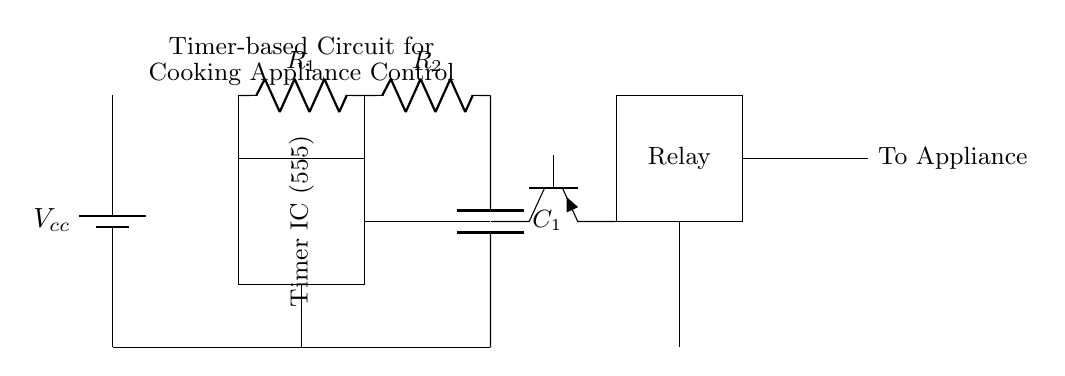What type of timer is used in this circuit? The circuit employs a 555 timer, which is indicated as "Timer IC (555)" in the diagram.
Answer: 555 timer What is the purpose of the capacitor in this circuit? The capacitor, labeled as C1, is used in conjunction with the resistors to determine the timing interval for the circuit, influencing how long the cooking appliance will be active.
Answer: Timing interval What is the role of the relay in this circuit? The relay acts as a switch that allows the circuit to control a higher power appliance by using a lower power signal from the timer and transistor.
Answer: Switch How many resistors are present in the circuit diagram? There are two resistors in the circuit, denoted as R1 and R2, which are used for setting the timing characteristics.
Answer: Two Which component is responsible for amplifying the signal to activate the relay? The transistor, represented as a PNP type, is responsible for amplifying the timer's output signal to activate the relay, allowing control of the appliance.
Answer: Transistor What are the connections between the timer and the relay? The timer connects to the base of the transistor, which then controls the relay, allowing the timer to switch the relay on or off based on the timing cycle.
Answer: Timer to transistor to relay What power supply voltage is used in this circuit? The circuit uses a battery labeled as Vcc, but the specific voltage isn’t listed in the schematic, often around 5V or 12V for 555 timers.
Answer: Vcc 